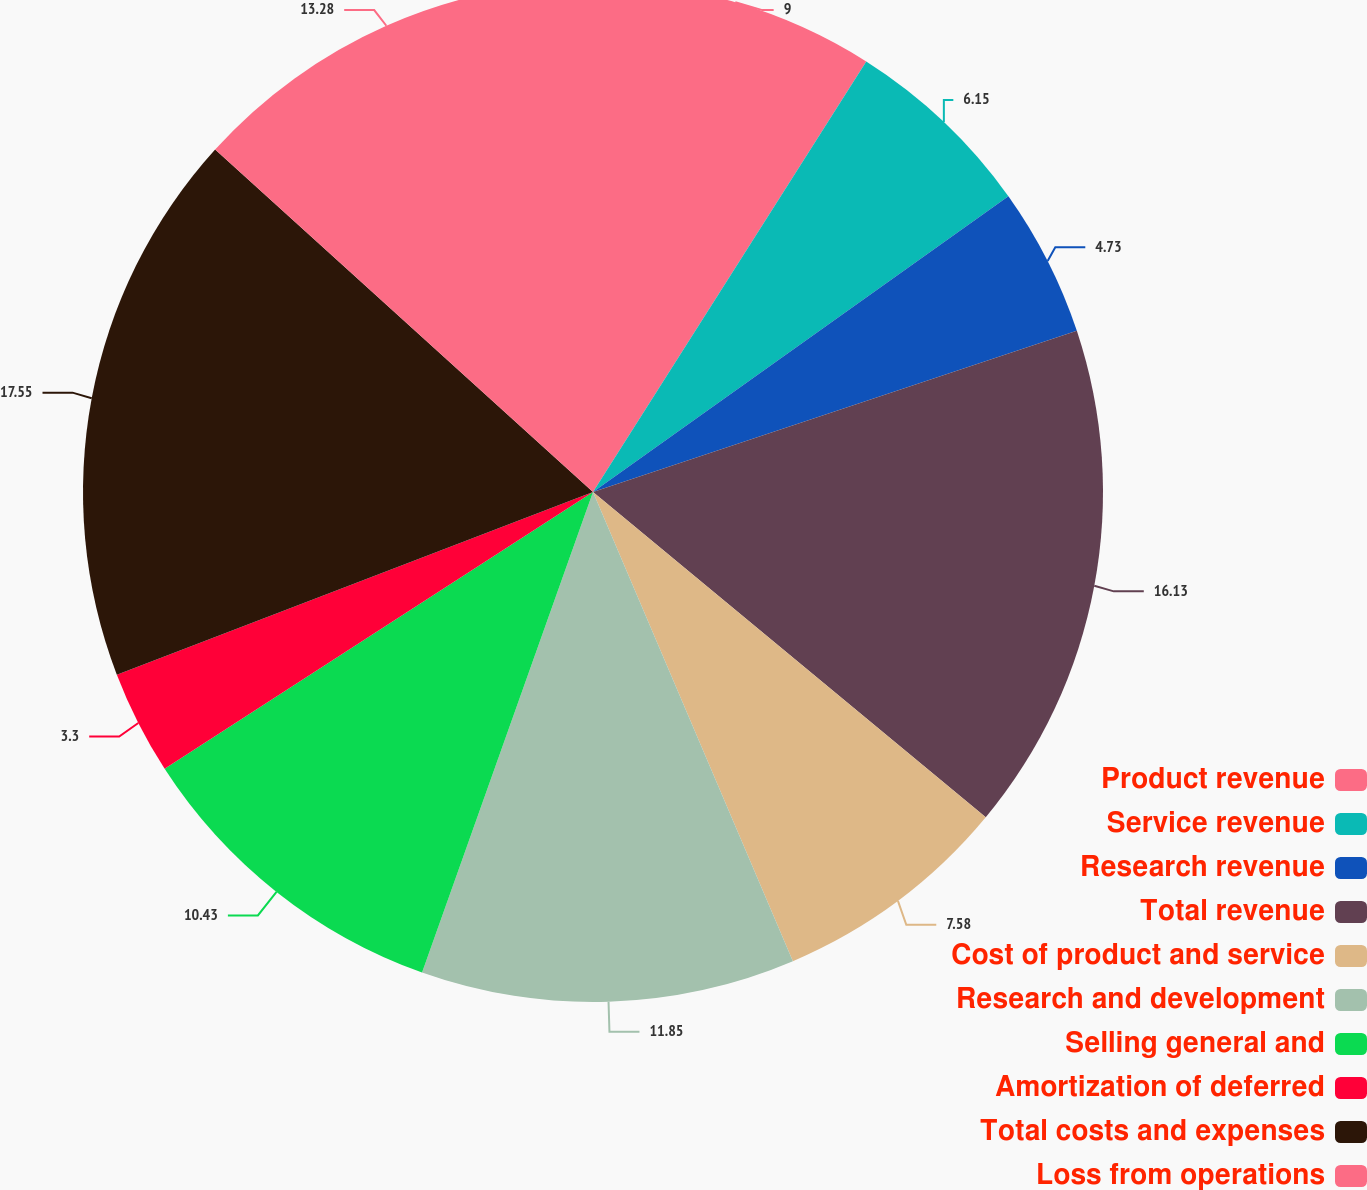<chart> <loc_0><loc_0><loc_500><loc_500><pie_chart><fcel>Product revenue<fcel>Service revenue<fcel>Research revenue<fcel>Total revenue<fcel>Cost of product and service<fcel>Research and development<fcel>Selling general and<fcel>Amortization of deferred<fcel>Total costs and expenses<fcel>Loss from operations<nl><fcel>9.0%<fcel>6.15%<fcel>4.73%<fcel>16.13%<fcel>7.58%<fcel>11.85%<fcel>10.43%<fcel>3.3%<fcel>17.55%<fcel>13.28%<nl></chart> 